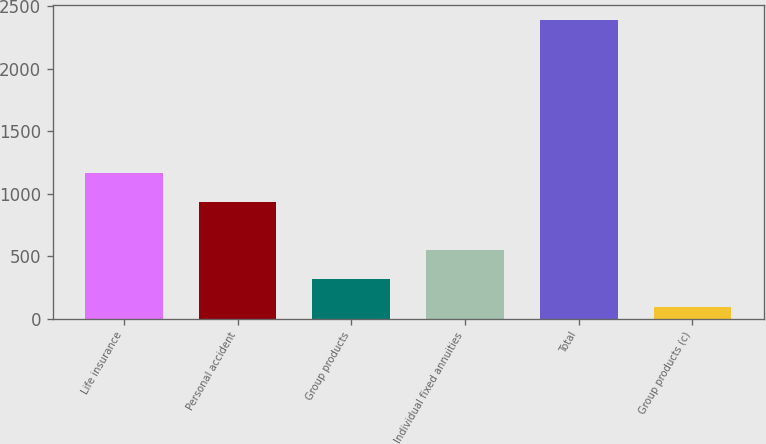Convert chart. <chart><loc_0><loc_0><loc_500><loc_500><bar_chart><fcel>Life insurance<fcel>Personal accident<fcel>Group products<fcel>Individual fixed annuities<fcel>Total<fcel>Group products (c)<nl><fcel>1162.3<fcel>932<fcel>320.3<fcel>550.6<fcel>2393<fcel>90<nl></chart> 